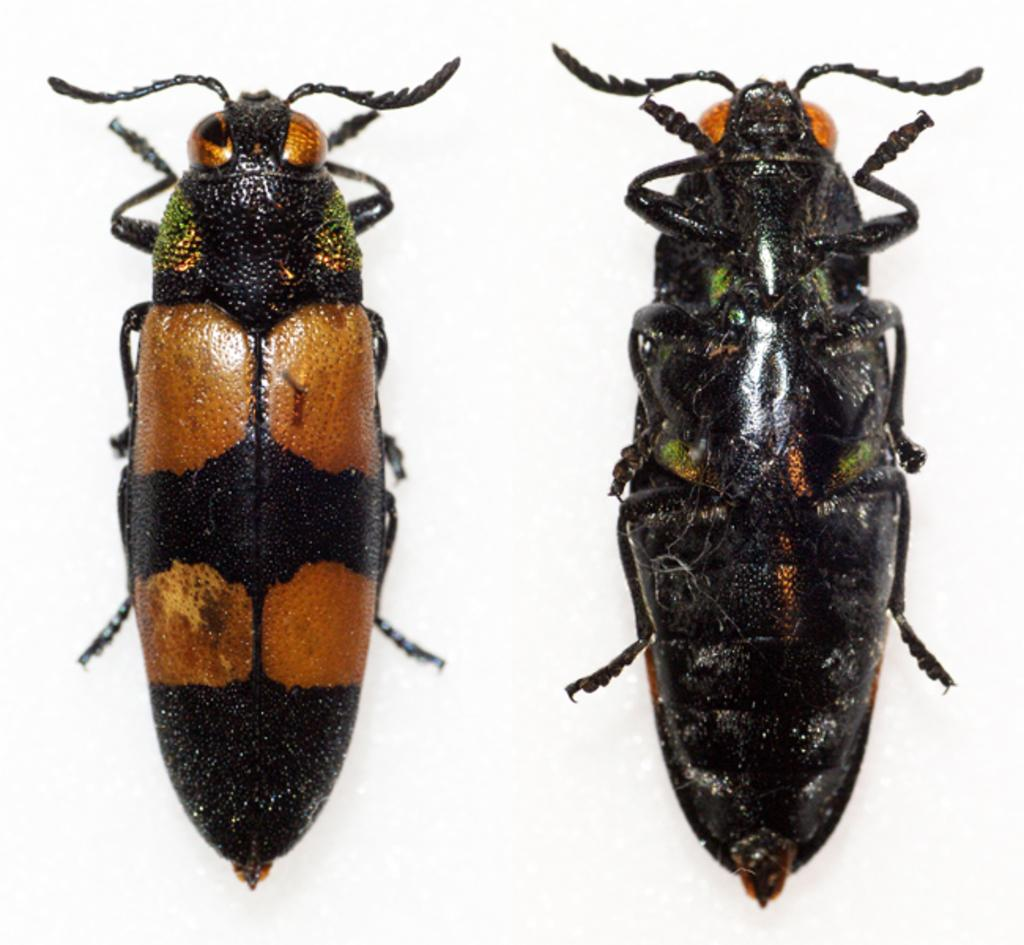How many insects are present in the image? There are two insects in the image. What feature do the insects have? The insects have legs. Where are the insects located in the image? The insects are on a surface. What color is the background of the image? The background of the image is white. What type of wren can be seen writing a message on the toothbrush in the image? There is no wren or toothbrush present in the image; it features two insects on a surface with a white background. 